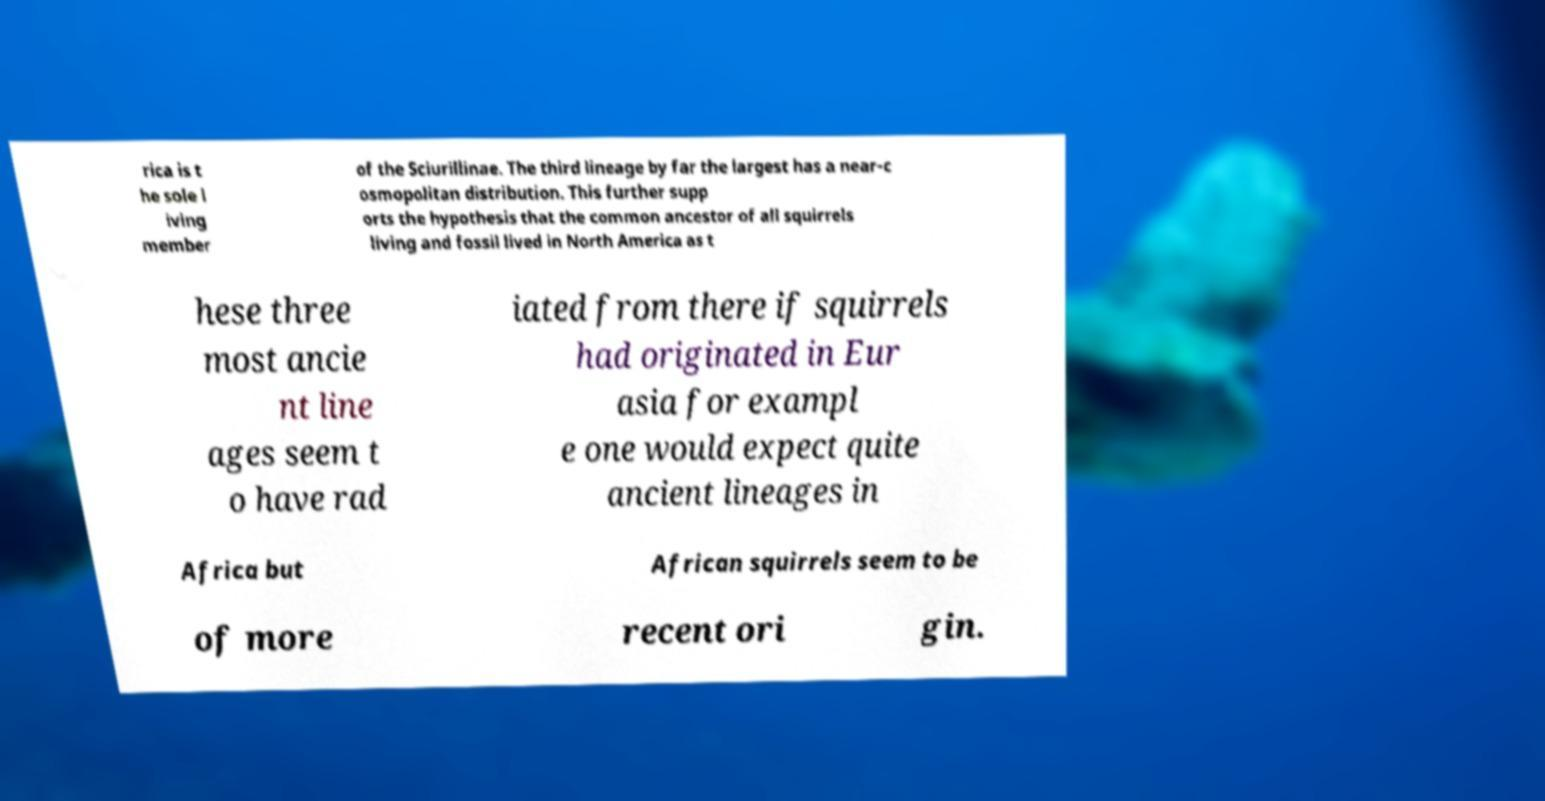Could you extract and type out the text from this image? rica is t he sole l iving member of the Sciurillinae. The third lineage by far the largest has a near-c osmopolitan distribution. This further supp orts the hypothesis that the common ancestor of all squirrels living and fossil lived in North America as t hese three most ancie nt line ages seem t o have rad iated from there if squirrels had originated in Eur asia for exampl e one would expect quite ancient lineages in Africa but African squirrels seem to be of more recent ori gin. 